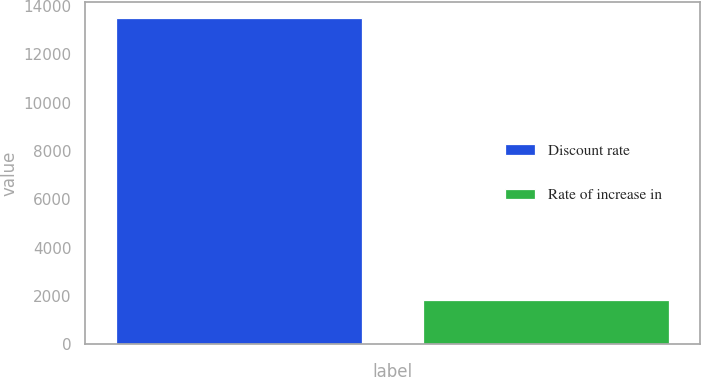Convert chart. <chart><loc_0><loc_0><loc_500><loc_500><bar_chart><fcel>Discount rate<fcel>Rate of increase in<nl><fcel>13479<fcel>1848<nl></chart> 